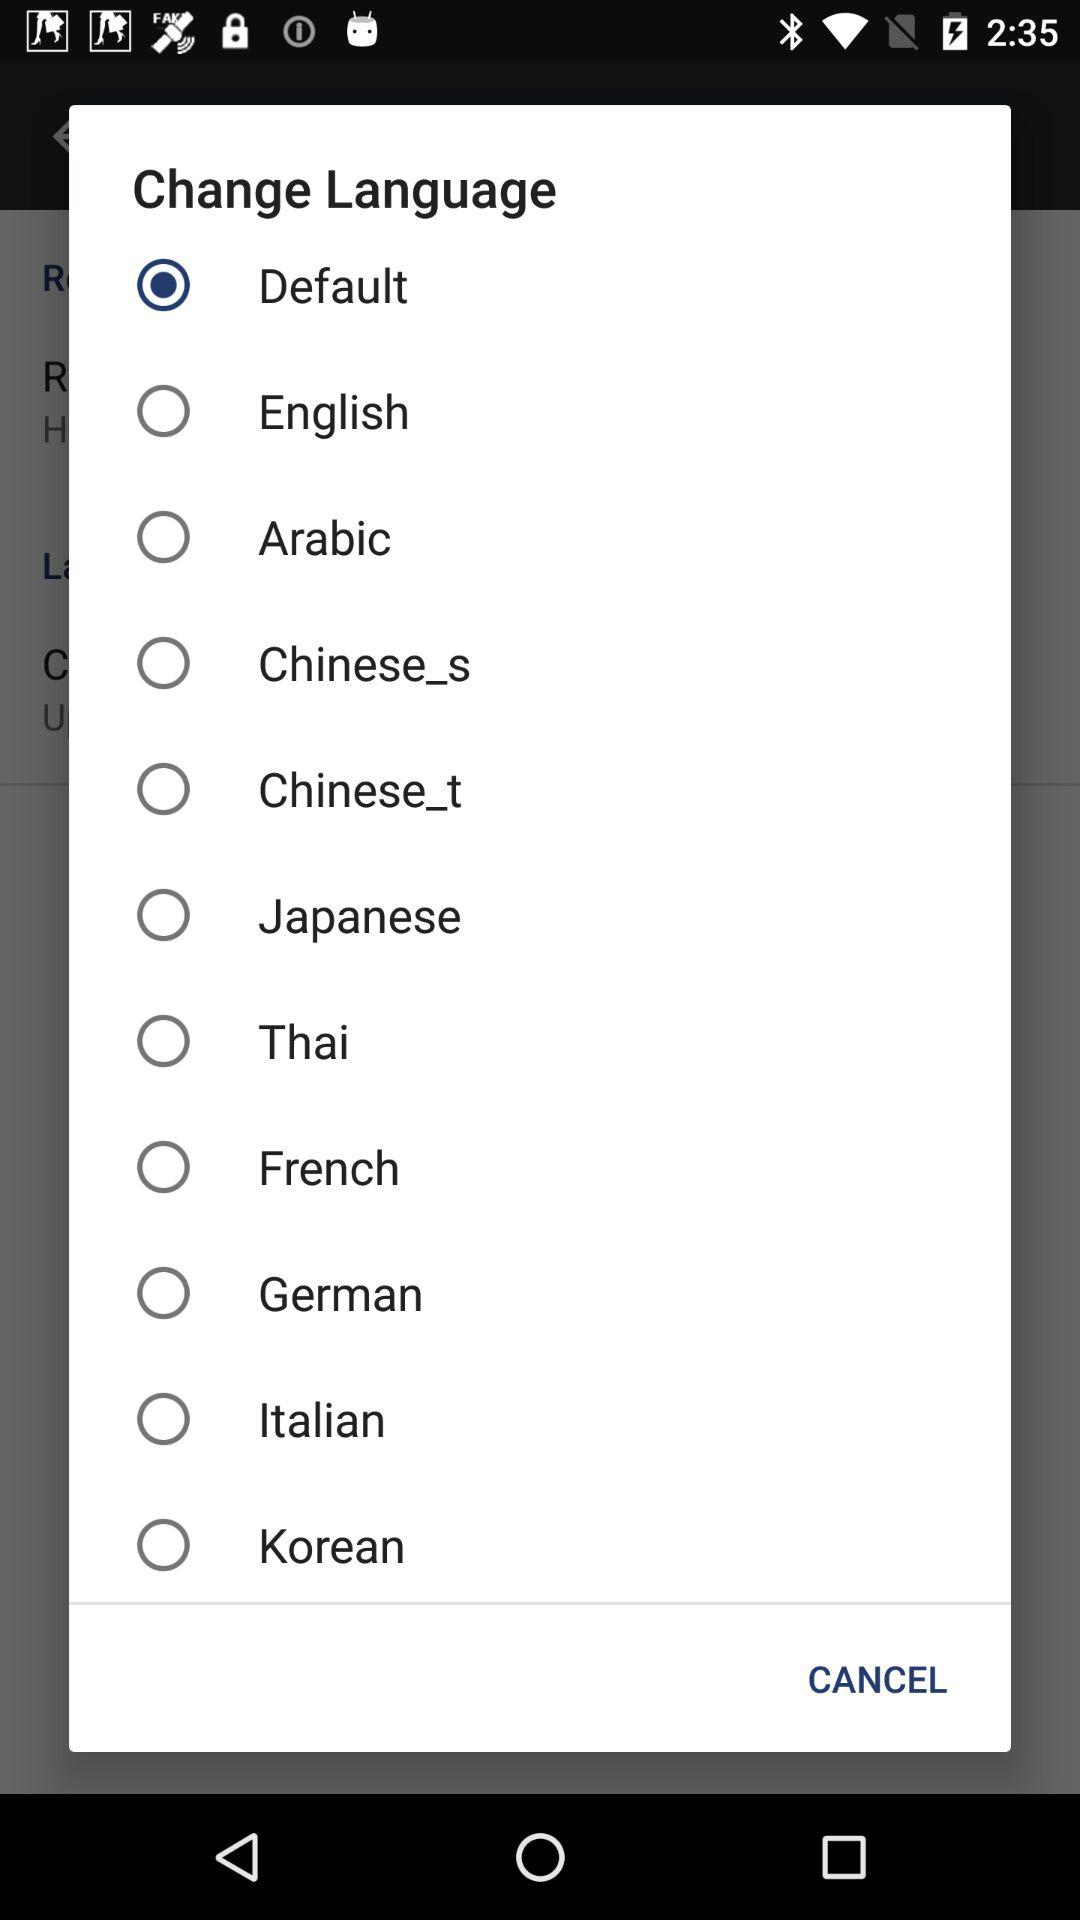How many languages are available?
Answer the question using a single word or phrase. 10 